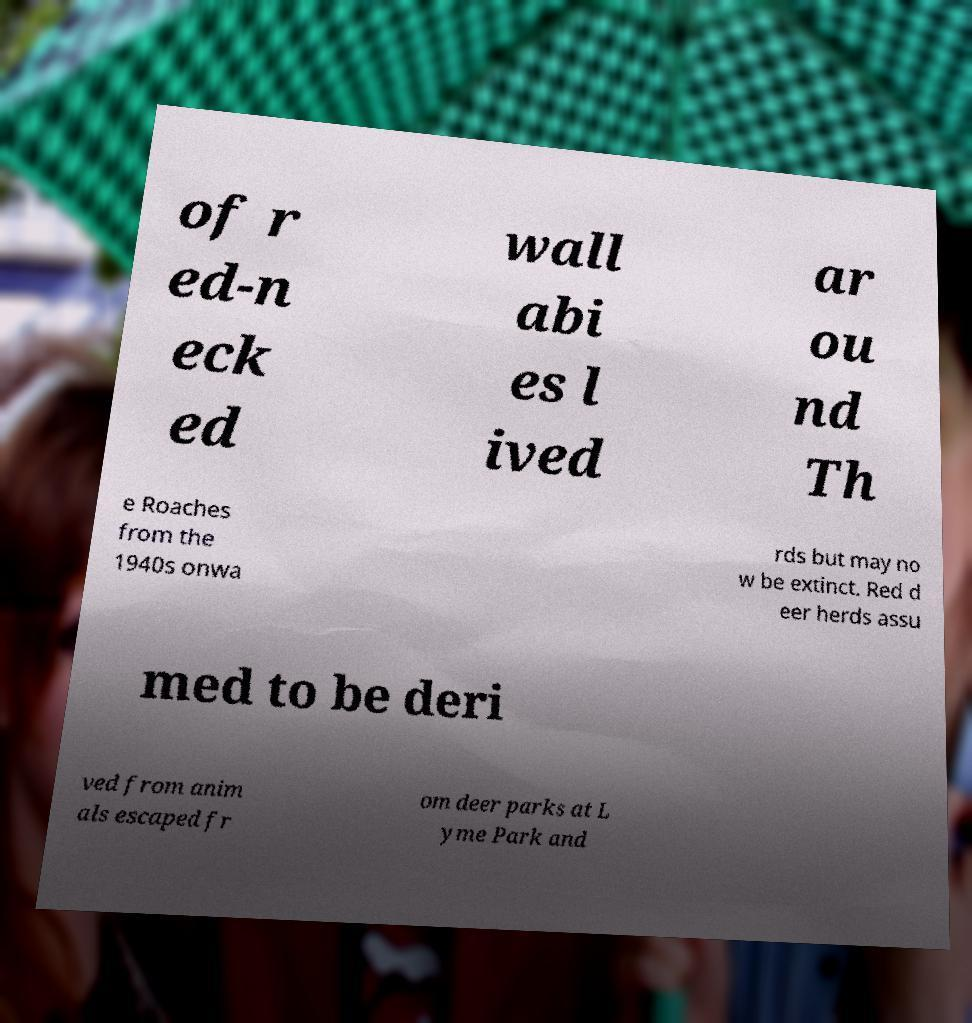Could you assist in decoding the text presented in this image and type it out clearly? of r ed-n eck ed wall abi es l ived ar ou nd Th e Roaches from the 1940s onwa rds but may no w be extinct. Red d eer herds assu med to be deri ved from anim als escaped fr om deer parks at L yme Park and 